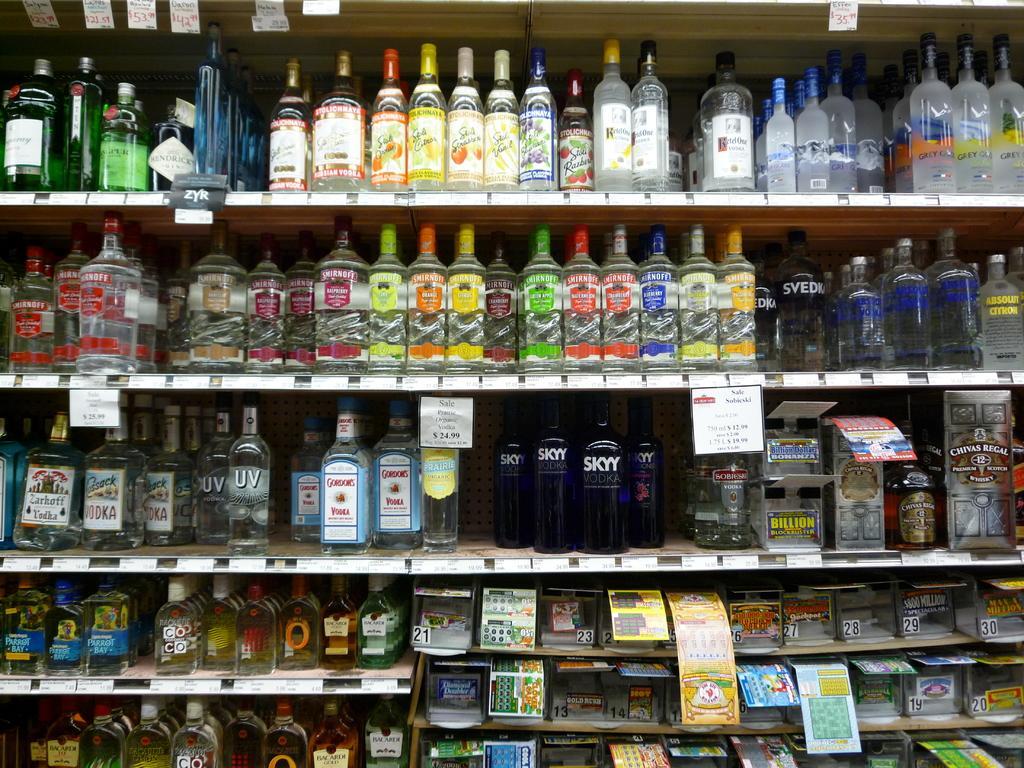Please provide a concise description of this image. In the foreground of this image, there are many bottles and boxes in the rack with price tags attached to it. 